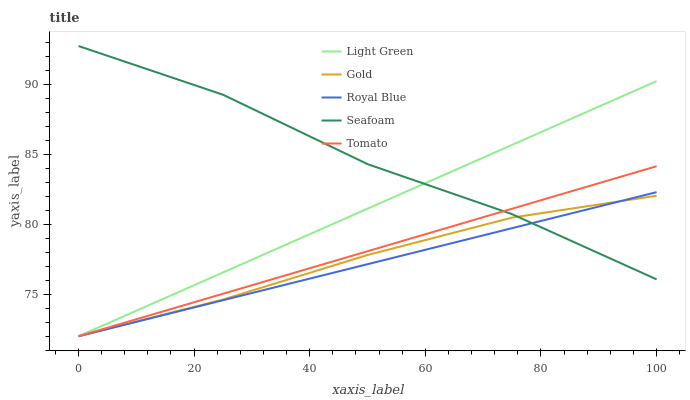Does Gold have the minimum area under the curve?
Answer yes or no. No. Does Gold have the maximum area under the curve?
Answer yes or no. No. Is Royal Blue the smoothest?
Answer yes or no. No. Is Royal Blue the roughest?
Answer yes or no. No. Does Seafoam have the lowest value?
Answer yes or no. No. Does Royal Blue have the highest value?
Answer yes or no. No. 